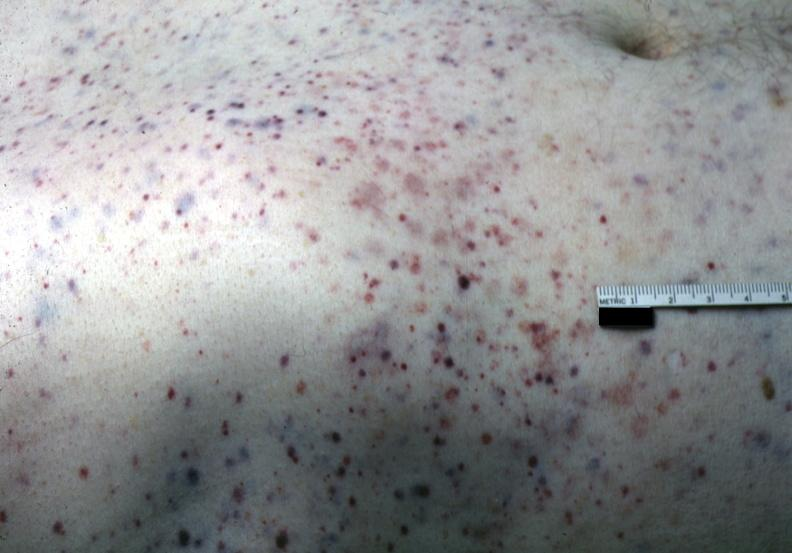does this image show white skin with multiple lesions?
Answer the question using a single word or phrase. Yes 